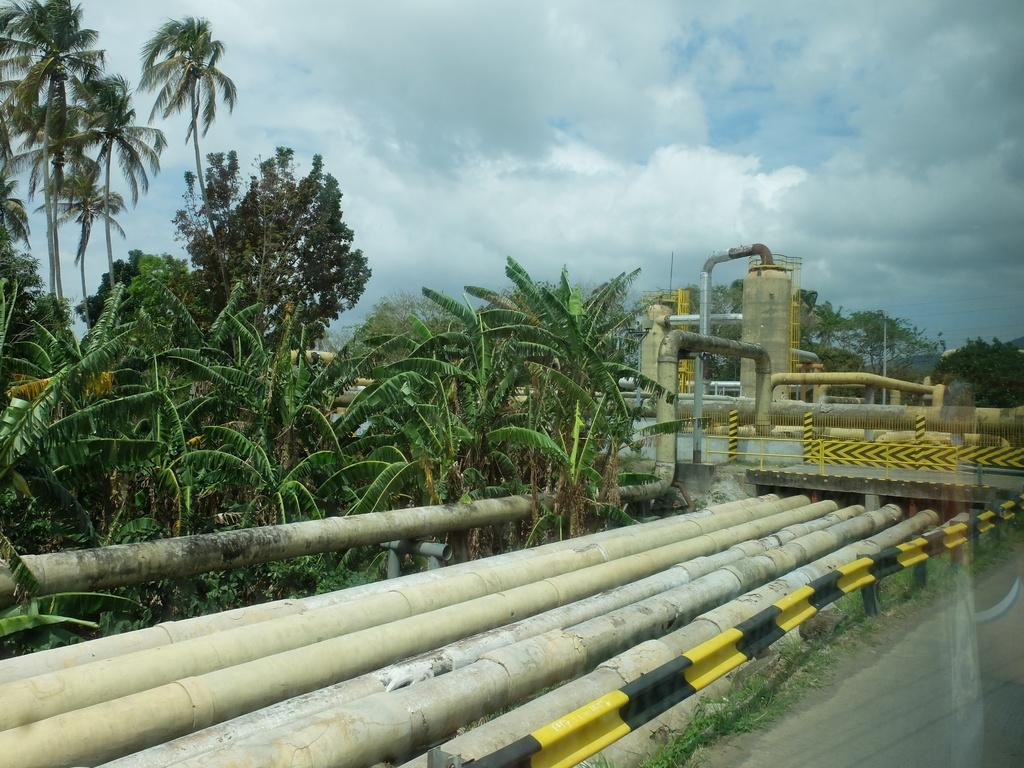What type of structures can be seen in the image? There are pipes, trees, and a bridge visible in the image. What is visible in the background of the image? The sky is visible in the image, and there are clouds present. Can you describe the natural elements in the image? There are trees and clouds visible in the image. What type of bean is being used as a writing instrument in the image? There is no bean or writing instrument present in the image. What type of vessel is being used to transport the pipes in the image? There is no vessel present in the image; the pipes are stationary. 